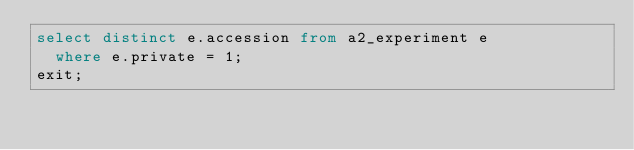<code> <loc_0><loc_0><loc_500><loc_500><_SQL_>select distinct e.accession from a2_experiment e
  where e.private = 1;
exit;
</code> 